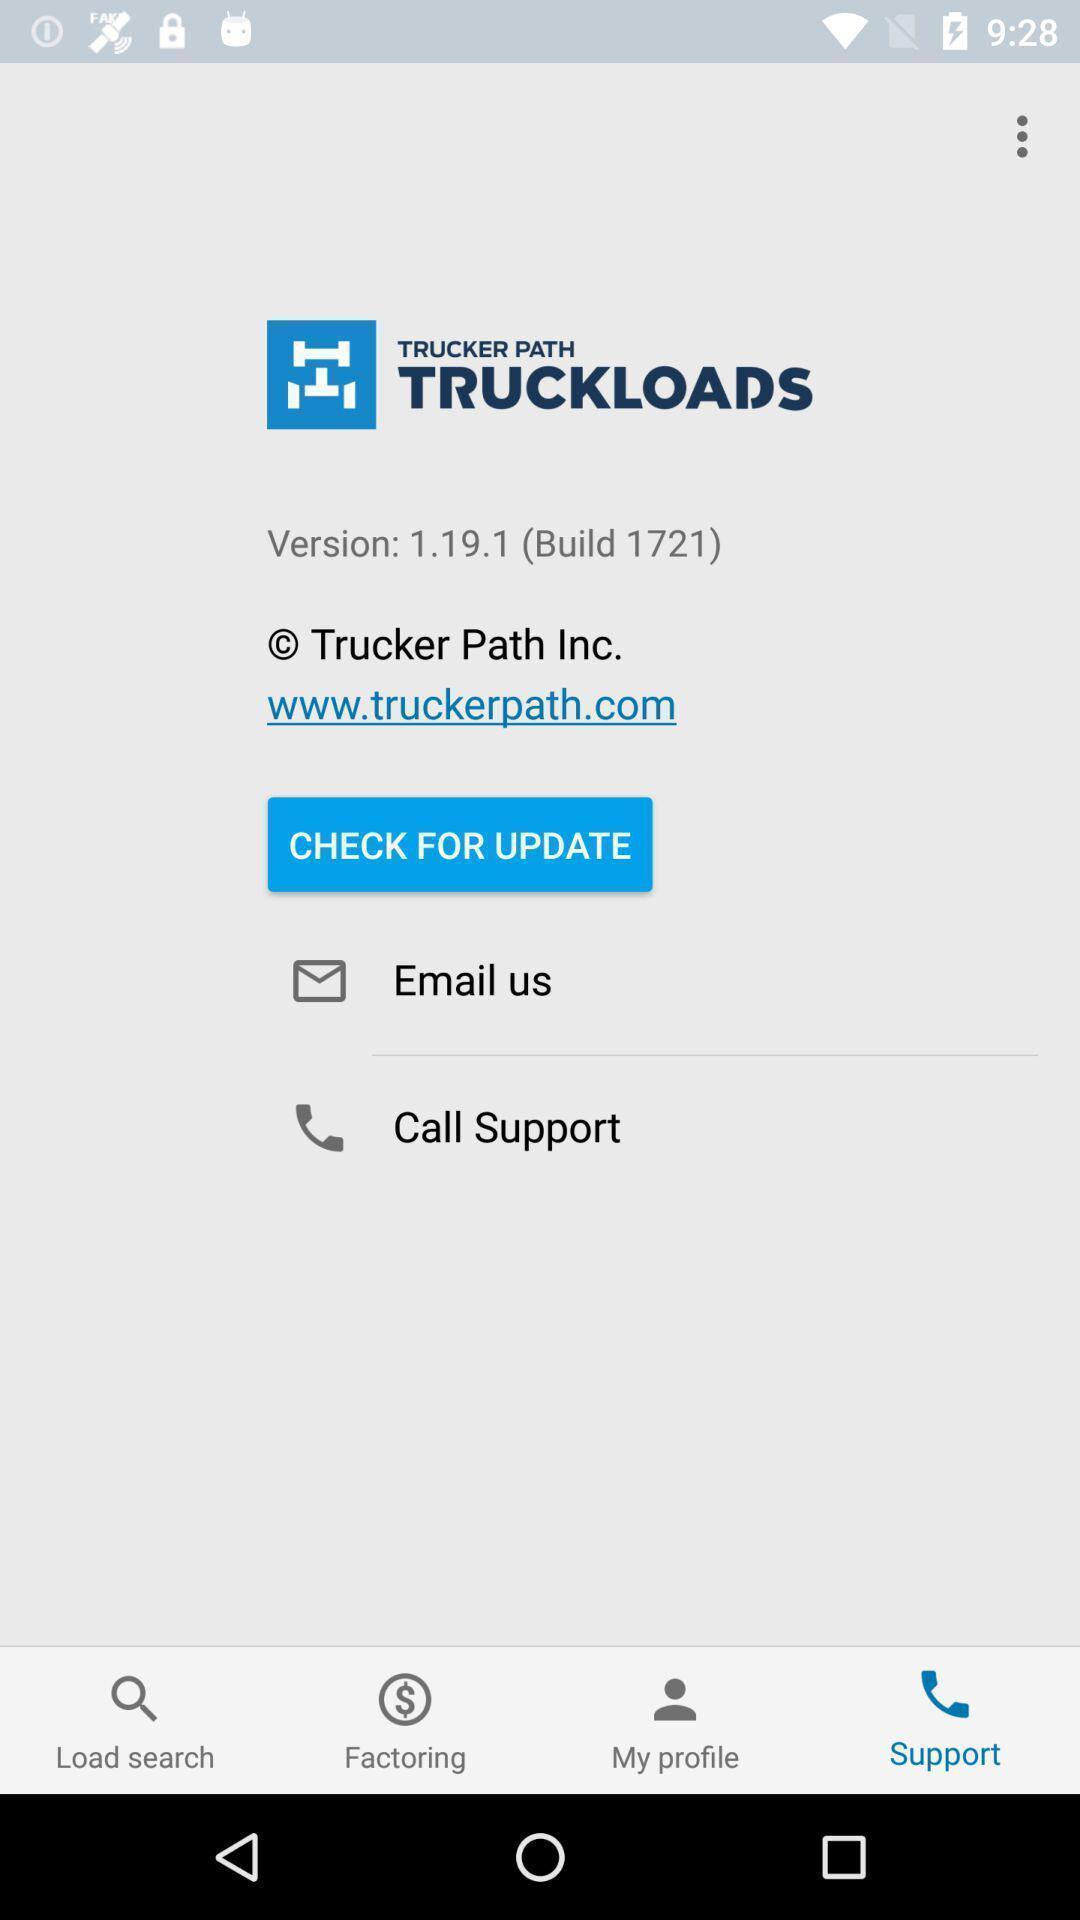Provide a description of this screenshot. Screen displaying multiple help options. 